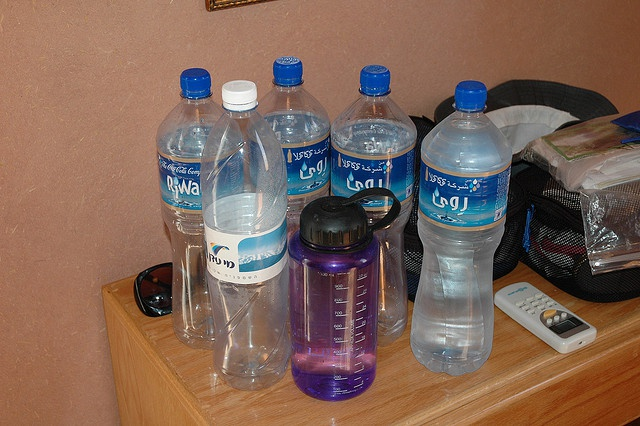Describe the objects in this image and their specific colors. I can see bottle in gray, darkgray, and lightgray tones, bottle in gray, darkgray, and blue tones, bottle in gray, black, and purple tones, bottle in gray, navy, blue, and darkgray tones, and bottle in gray, brown, and darkgray tones in this image. 